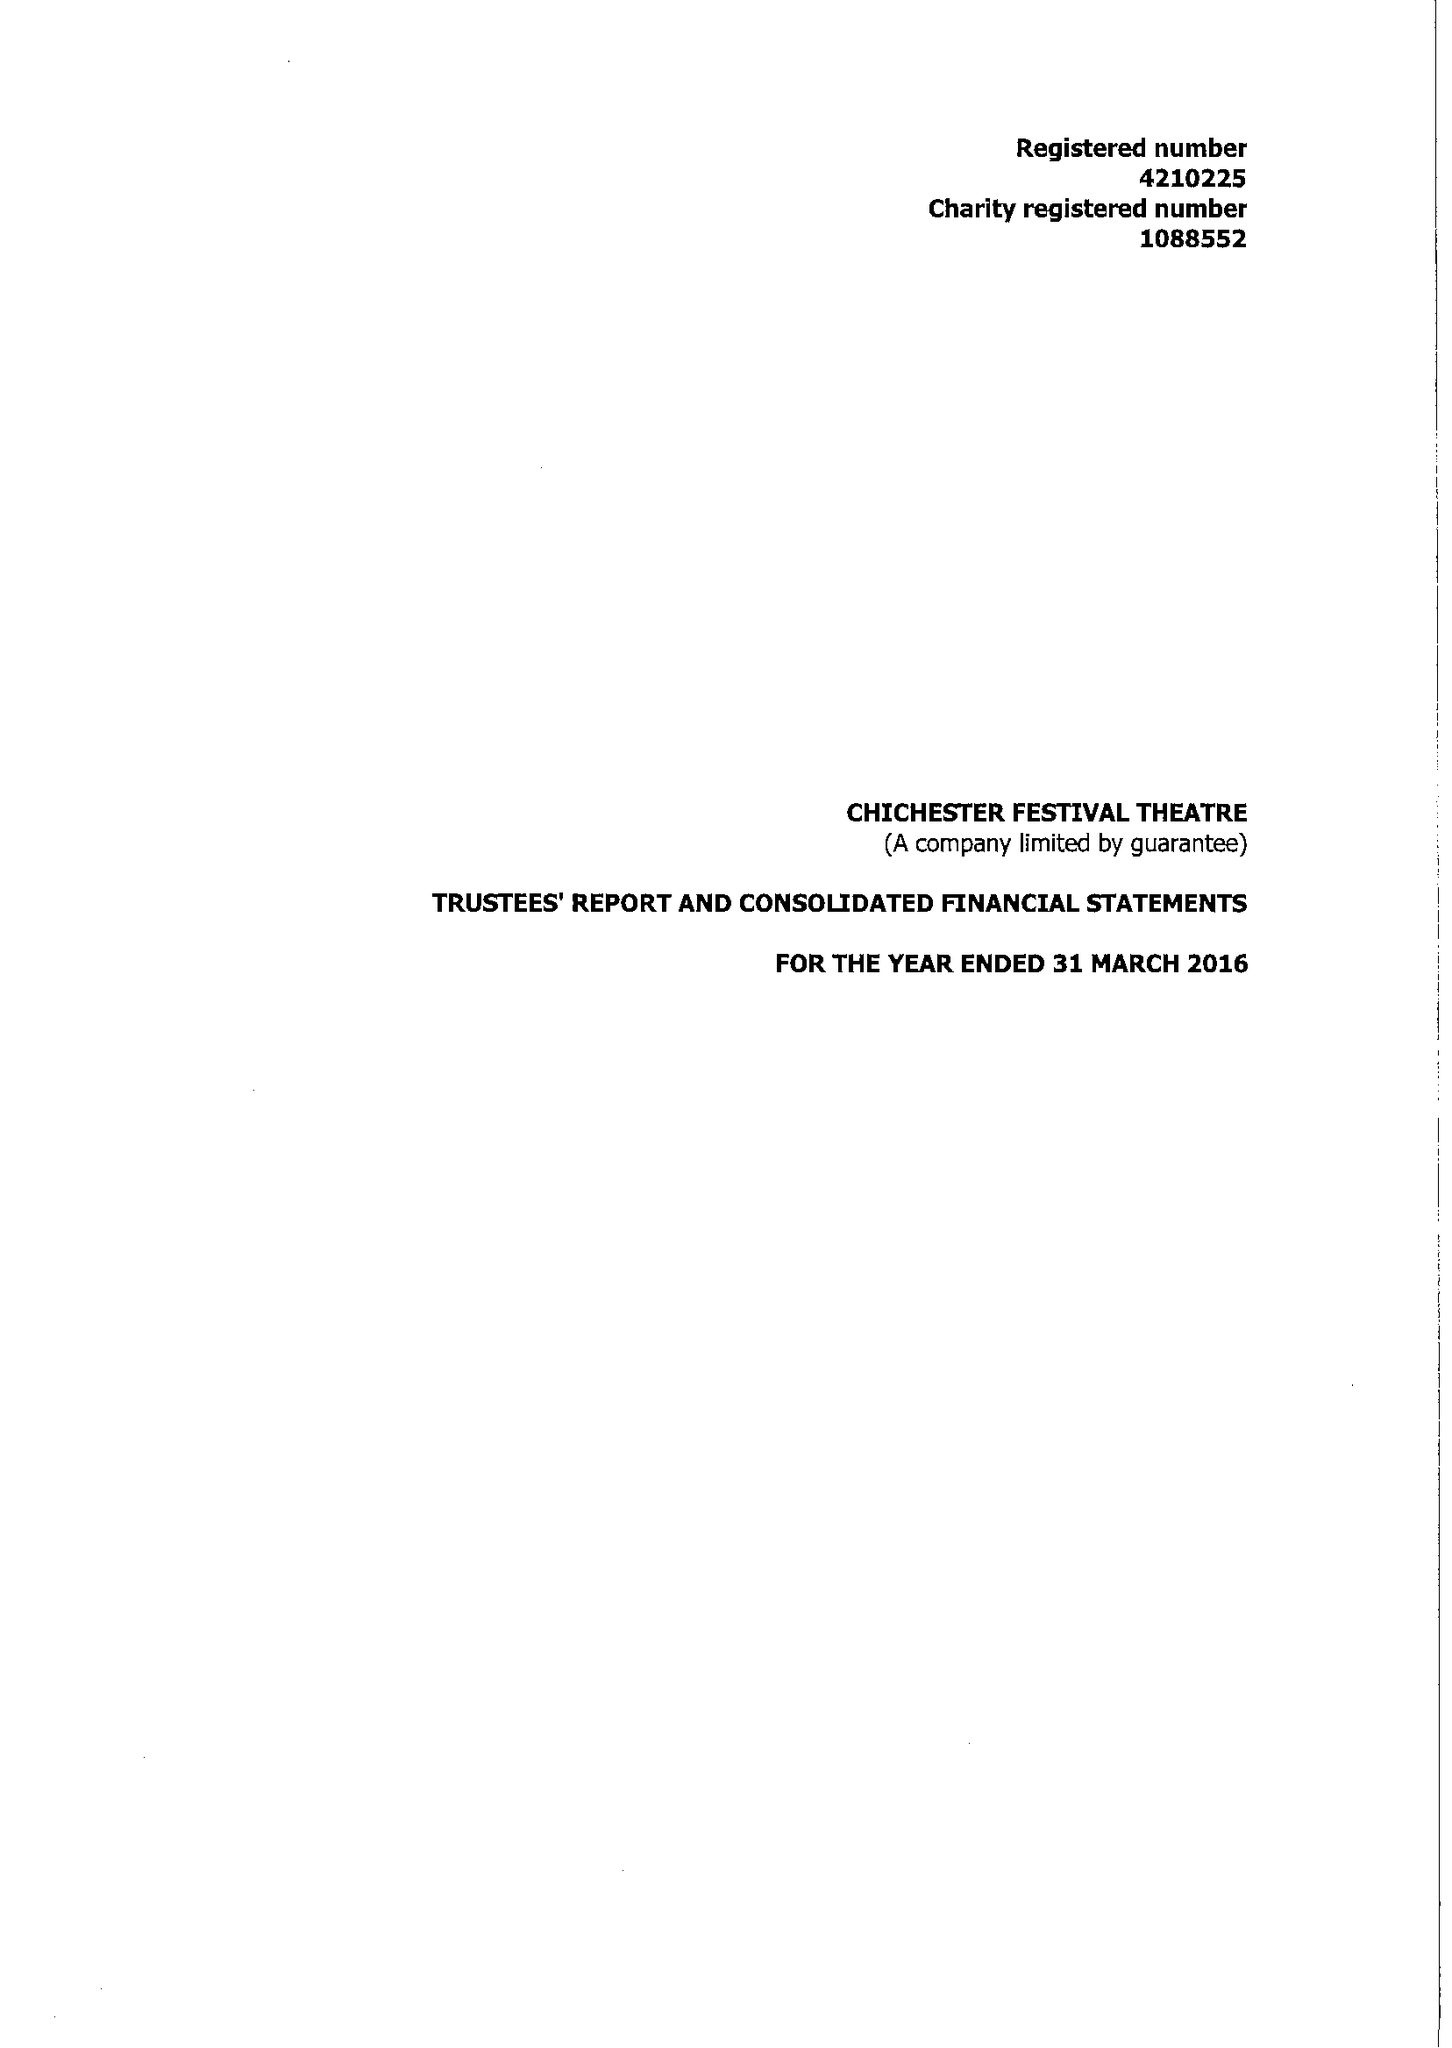What is the value for the spending_annually_in_british_pounds?
Answer the question using a single word or phrase. 15352744.00 